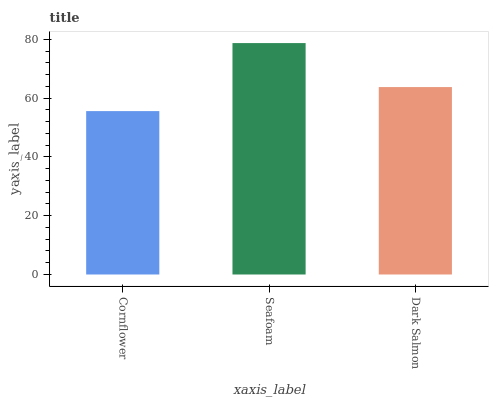Is Dark Salmon the minimum?
Answer yes or no. No. Is Dark Salmon the maximum?
Answer yes or no. No. Is Seafoam greater than Dark Salmon?
Answer yes or no. Yes. Is Dark Salmon less than Seafoam?
Answer yes or no. Yes. Is Dark Salmon greater than Seafoam?
Answer yes or no. No. Is Seafoam less than Dark Salmon?
Answer yes or no. No. Is Dark Salmon the high median?
Answer yes or no. Yes. Is Dark Salmon the low median?
Answer yes or no. Yes. Is Cornflower the high median?
Answer yes or no. No. Is Seafoam the low median?
Answer yes or no. No. 